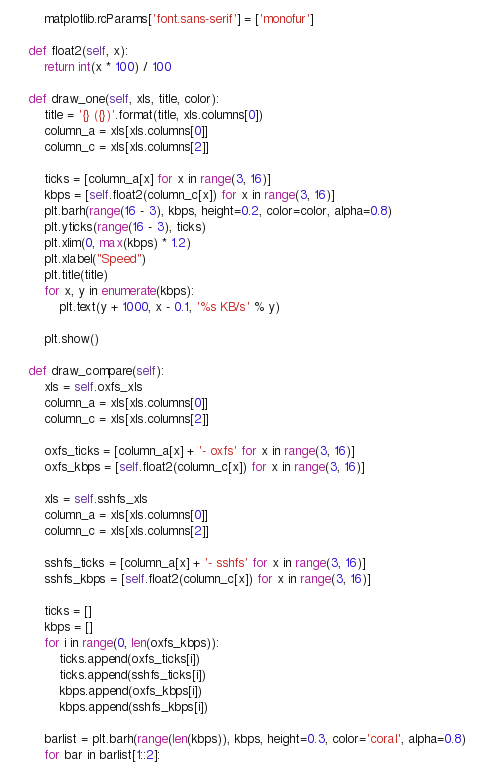Convert code to text. <code><loc_0><loc_0><loc_500><loc_500><_Python_>        matplotlib.rcParams['font.sans-serif'] = ['monofur']

    def float2(self, x):
        return int(x * 100) / 100

    def draw_one(self, xls, title, color):
        title = '{} ({})'.format(title, xls.columns[0])
        column_a = xls[xls.columns[0]]
        column_c = xls[xls.columns[2]]

        ticks = [column_a[x] for x in range(3, 16)]
        kbps = [self.float2(column_c[x]) for x in range(3, 16)]
        plt.barh(range(16 - 3), kbps, height=0.2, color=color, alpha=0.8)
        plt.yticks(range(16 - 3), ticks)
        plt.xlim(0, max(kbps) * 1.2)
        plt.xlabel("Speed")
        plt.title(title)
        for x, y in enumerate(kbps):
            plt.text(y + 1000, x - 0.1, '%s KB/s' % y)

        plt.show()

    def draw_compare(self):
        xls = self.oxfs_xls
        column_a = xls[xls.columns[0]]
        column_c = xls[xls.columns[2]]

        oxfs_ticks = [column_a[x] + '- oxfs' for x in range(3, 16)]
        oxfs_kbps = [self.float2(column_c[x]) for x in range(3, 16)]

        xls = self.sshfs_xls
        column_a = xls[xls.columns[0]]
        column_c = xls[xls.columns[2]]

        sshfs_ticks = [column_a[x] + '- sshfs' for x in range(3, 16)]
        sshfs_kbps = [self.float2(column_c[x]) for x in range(3, 16)]

        ticks = []
        kbps = []
        for i in range(0, len(oxfs_kbps)):
            ticks.append(oxfs_ticks[i])
            ticks.append(sshfs_ticks[i])
            kbps.append(oxfs_kbps[i])
            kbps.append(sshfs_kbps[i])

        barlist = plt.barh(range(len(kbps)), kbps, height=0.3, color='coral', alpha=0.8)
        for bar in barlist[1::2]:</code> 